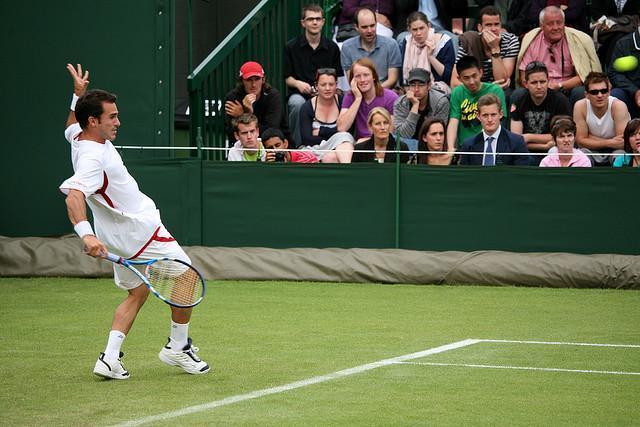How many people can you see?
Give a very brief answer. 12. 